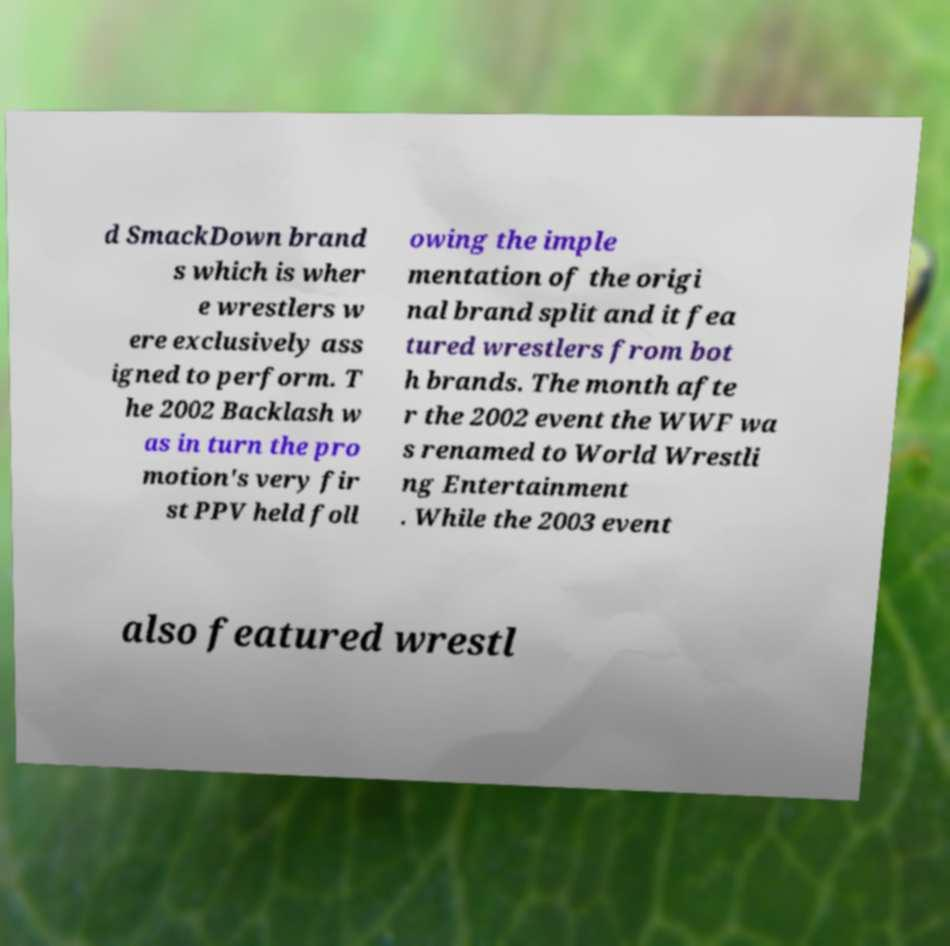What messages or text are displayed in this image? I need them in a readable, typed format. d SmackDown brand s which is wher e wrestlers w ere exclusively ass igned to perform. T he 2002 Backlash w as in turn the pro motion's very fir st PPV held foll owing the imple mentation of the origi nal brand split and it fea tured wrestlers from bot h brands. The month afte r the 2002 event the WWF wa s renamed to World Wrestli ng Entertainment . While the 2003 event also featured wrestl 